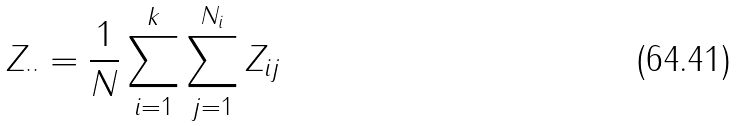Convert formula to latex. <formula><loc_0><loc_0><loc_500><loc_500>Z _ { \cdot \cdot } = \frac { 1 } { N } \sum _ { i = 1 } ^ { k } \sum _ { j = 1 } ^ { N _ { i } } Z _ { i j }</formula> 